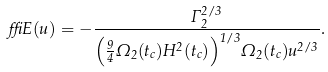Convert formula to latex. <formula><loc_0><loc_0><loc_500><loc_500>\delta E ( u ) = - \frac { \Gamma _ { 2 } ^ { 2 / 3 } } { { \left ( \frac { 9 } { 4 } \Omega _ { 2 } ( t _ { c } ) H ^ { 2 } ( t _ { c } ) \right ) } ^ { 1 / 3 } \Omega _ { 2 } ( t _ { c } ) u ^ { 2 / 3 } } .</formula> 